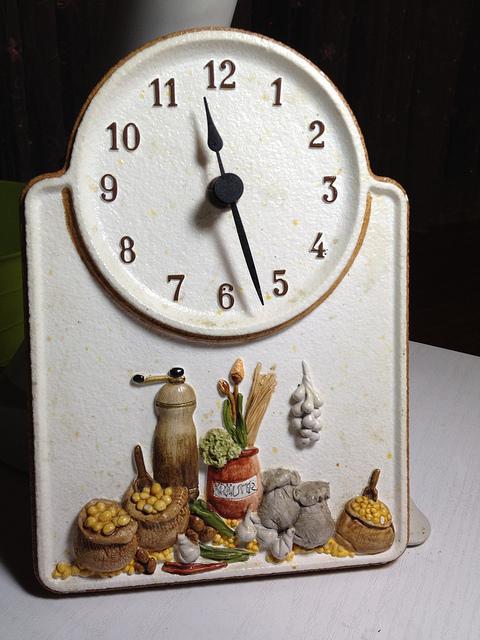Is the design raised?
Be succinct. Yes. What color is the clock?
Concise answer only. White. Is it dinner time?
Answer briefly. No. 